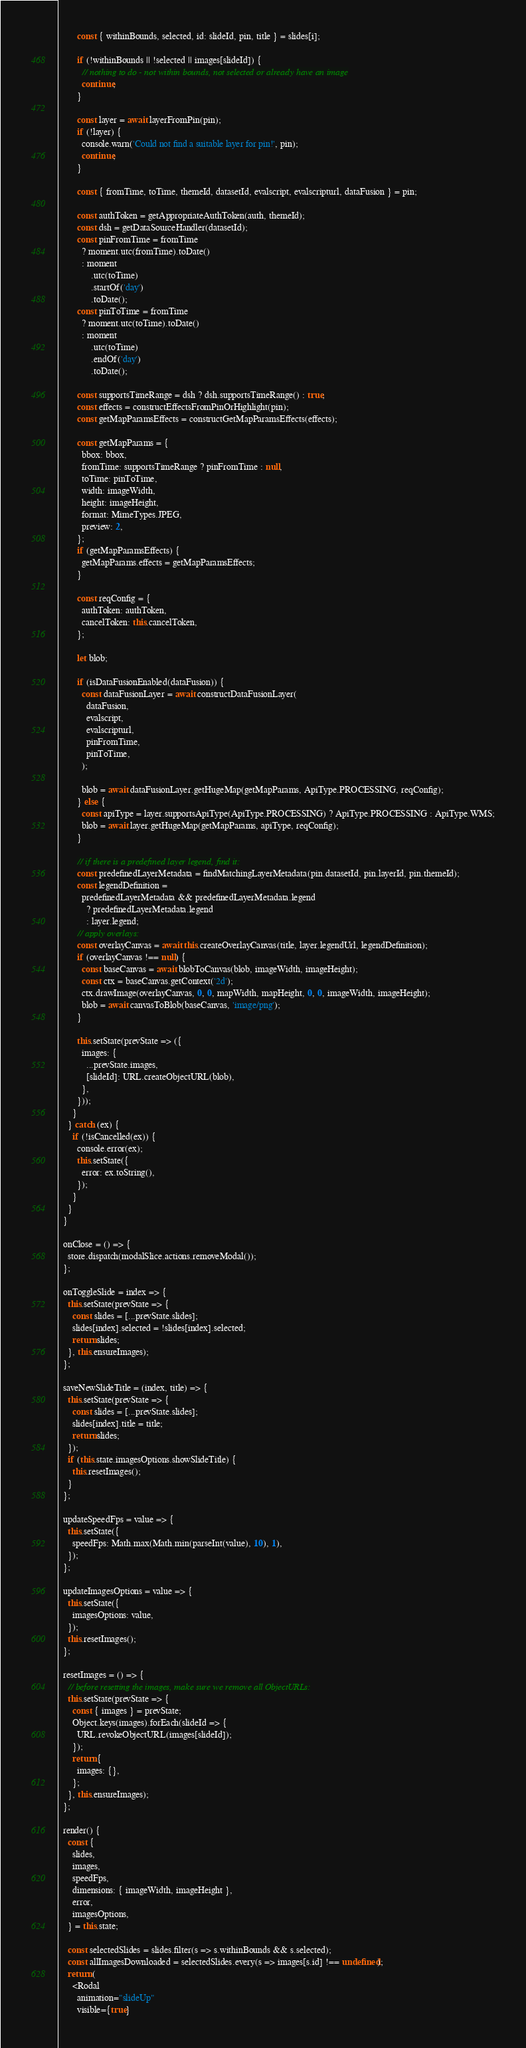Convert code to text. <code><loc_0><loc_0><loc_500><loc_500><_JavaScript_>        const { withinBounds, selected, id: slideId, pin, title } = slides[i];

        if (!withinBounds || !selected || images[slideId]) {
          // nothing to do - not within bounds, not selected or already have an image
          continue;
        }

        const layer = await layerFromPin(pin);
        if (!layer) {
          console.warn('Could not find a suitable layer for pin!', pin);
          continue;
        }

        const { fromTime, toTime, themeId, datasetId, evalscript, evalscripturl, dataFusion } = pin;

        const authToken = getAppropriateAuthToken(auth, themeId);
        const dsh = getDataSourceHandler(datasetId);
        const pinFromTime = fromTime
          ? moment.utc(fromTime).toDate()
          : moment
              .utc(toTime)
              .startOf('day')
              .toDate();
        const pinToTime = fromTime
          ? moment.utc(toTime).toDate()
          : moment
              .utc(toTime)
              .endOf('day')
              .toDate();

        const supportsTimeRange = dsh ? dsh.supportsTimeRange() : true;
        const effects = constructEffectsFromPinOrHighlight(pin);
        const getMapParamsEffects = constructGetMapParamsEffects(effects);

        const getMapParams = {
          bbox: bbox,
          fromTime: supportsTimeRange ? pinFromTime : null,
          toTime: pinToTime,
          width: imageWidth,
          height: imageHeight,
          format: MimeTypes.JPEG,
          preview: 2,
        };
        if (getMapParamsEffects) {
          getMapParams.effects = getMapParamsEffects;
        }

        const reqConfig = {
          authToken: authToken,
          cancelToken: this.cancelToken,
        };

        let blob;

        if (isDataFusionEnabled(dataFusion)) {
          const dataFusionLayer = await constructDataFusionLayer(
            dataFusion,
            evalscript,
            evalscripturl,
            pinFromTime,
            pinToTime,
          );

          blob = await dataFusionLayer.getHugeMap(getMapParams, ApiType.PROCESSING, reqConfig);
        } else {
          const apiType = layer.supportsApiType(ApiType.PROCESSING) ? ApiType.PROCESSING : ApiType.WMS;
          blob = await layer.getHugeMap(getMapParams, apiType, reqConfig);
        }

        // if there is a predefined layer legend, find it:
        const predefinedLayerMetadata = findMatchingLayerMetadata(pin.datasetId, pin.layerId, pin.themeId);
        const legendDefinition =
          predefinedLayerMetadata && predefinedLayerMetadata.legend
            ? predefinedLayerMetadata.legend
            : layer.legend;
        // apply overlays:
        const overlayCanvas = await this.createOverlayCanvas(title, layer.legendUrl, legendDefinition);
        if (overlayCanvas !== null) {
          const baseCanvas = await blobToCanvas(blob, imageWidth, imageHeight);
          const ctx = baseCanvas.getContext('2d');
          ctx.drawImage(overlayCanvas, 0, 0, mapWidth, mapHeight, 0, 0, imageWidth, imageHeight);
          blob = await canvasToBlob(baseCanvas, 'image/png');
        }

        this.setState(prevState => ({
          images: {
            ...prevState.images,
            [slideId]: URL.createObjectURL(blob),
          },
        }));
      }
    } catch (ex) {
      if (!isCancelled(ex)) {
        console.error(ex);
        this.setState({
          error: ex.toString(),
        });
      }
    }
  }

  onClose = () => {
    store.dispatch(modalSlice.actions.removeModal());
  };

  onToggleSlide = index => {
    this.setState(prevState => {
      const slides = [...prevState.slides];
      slides[index].selected = !slides[index].selected;
      return slides;
    }, this.ensureImages);
  };

  saveNewSlideTitle = (index, title) => {
    this.setState(prevState => {
      const slides = [...prevState.slides];
      slides[index].title = title;
      return slides;
    });
    if (this.state.imagesOptions.showSlideTitle) {
      this.resetImages();
    }
  };

  updateSpeedFps = value => {
    this.setState({
      speedFps: Math.max(Math.min(parseInt(value), 10), 1),
    });
  };

  updateImagesOptions = value => {
    this.setState({
      imagesOptions: value,
    });
    this.resetImages();
  };

  resetImages = () => {
    // before resetting the images, make sure we remove all ObjectURLs:
    this.setState(prevState => {
      const { images } = prevState;
      Object.keys(images).forEach(slideId => {
        URL.revokeObjectURL(images[slideId]);
      });
      return {
        images: {},
      };
    }, this.ensureImages);
  };

  render() {
    const {
      slides,
      images,
      speedFps,
      dimensions: { imageWidth, imageHeight },
      error,
      imagesOptions,
    } = this.state;

    const selectedSlides = slides.filter(s => s.withinBounds && s.selected);
    const allImagesDownloaded = selectedSlides.every(s => images[s.id] !== undefined);
    return (
      <Rodal
        animation="slideUp"
        visible={true}</code> 